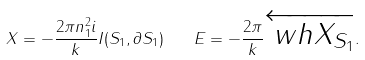<formula> <loc_0><loc_0><loc_500><loc_500>X = - \frac { 2 \pi n _ { 1 } ^ { 2 } i } { k } I ( S _ { 1 } , \partial S _ { 1 } ) \quad E = - \frac { 2 \pi } { k } \overleftarrow { \ w h { X } _ { S _ { 1 } } } .</formula> 